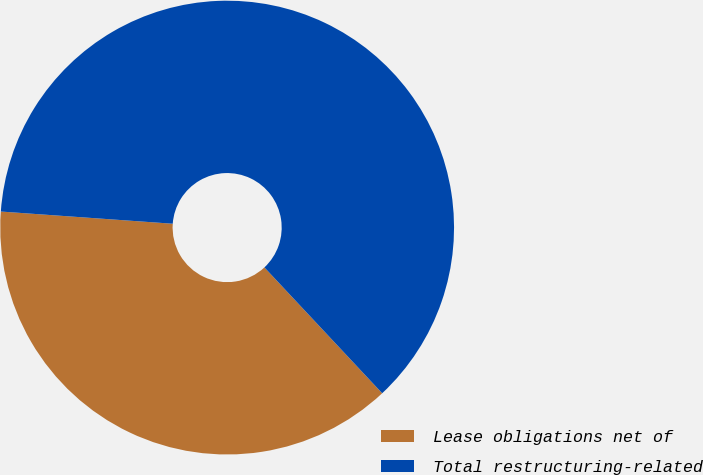Convert chart. <chart><loc_0><loc_0><loc_500><loc_500><pie_chart><fcel>Lease obligations net of<fcel>Total restructuring-related<nl><fcel>38.1%<fcel>61.9%<nl></chart> 